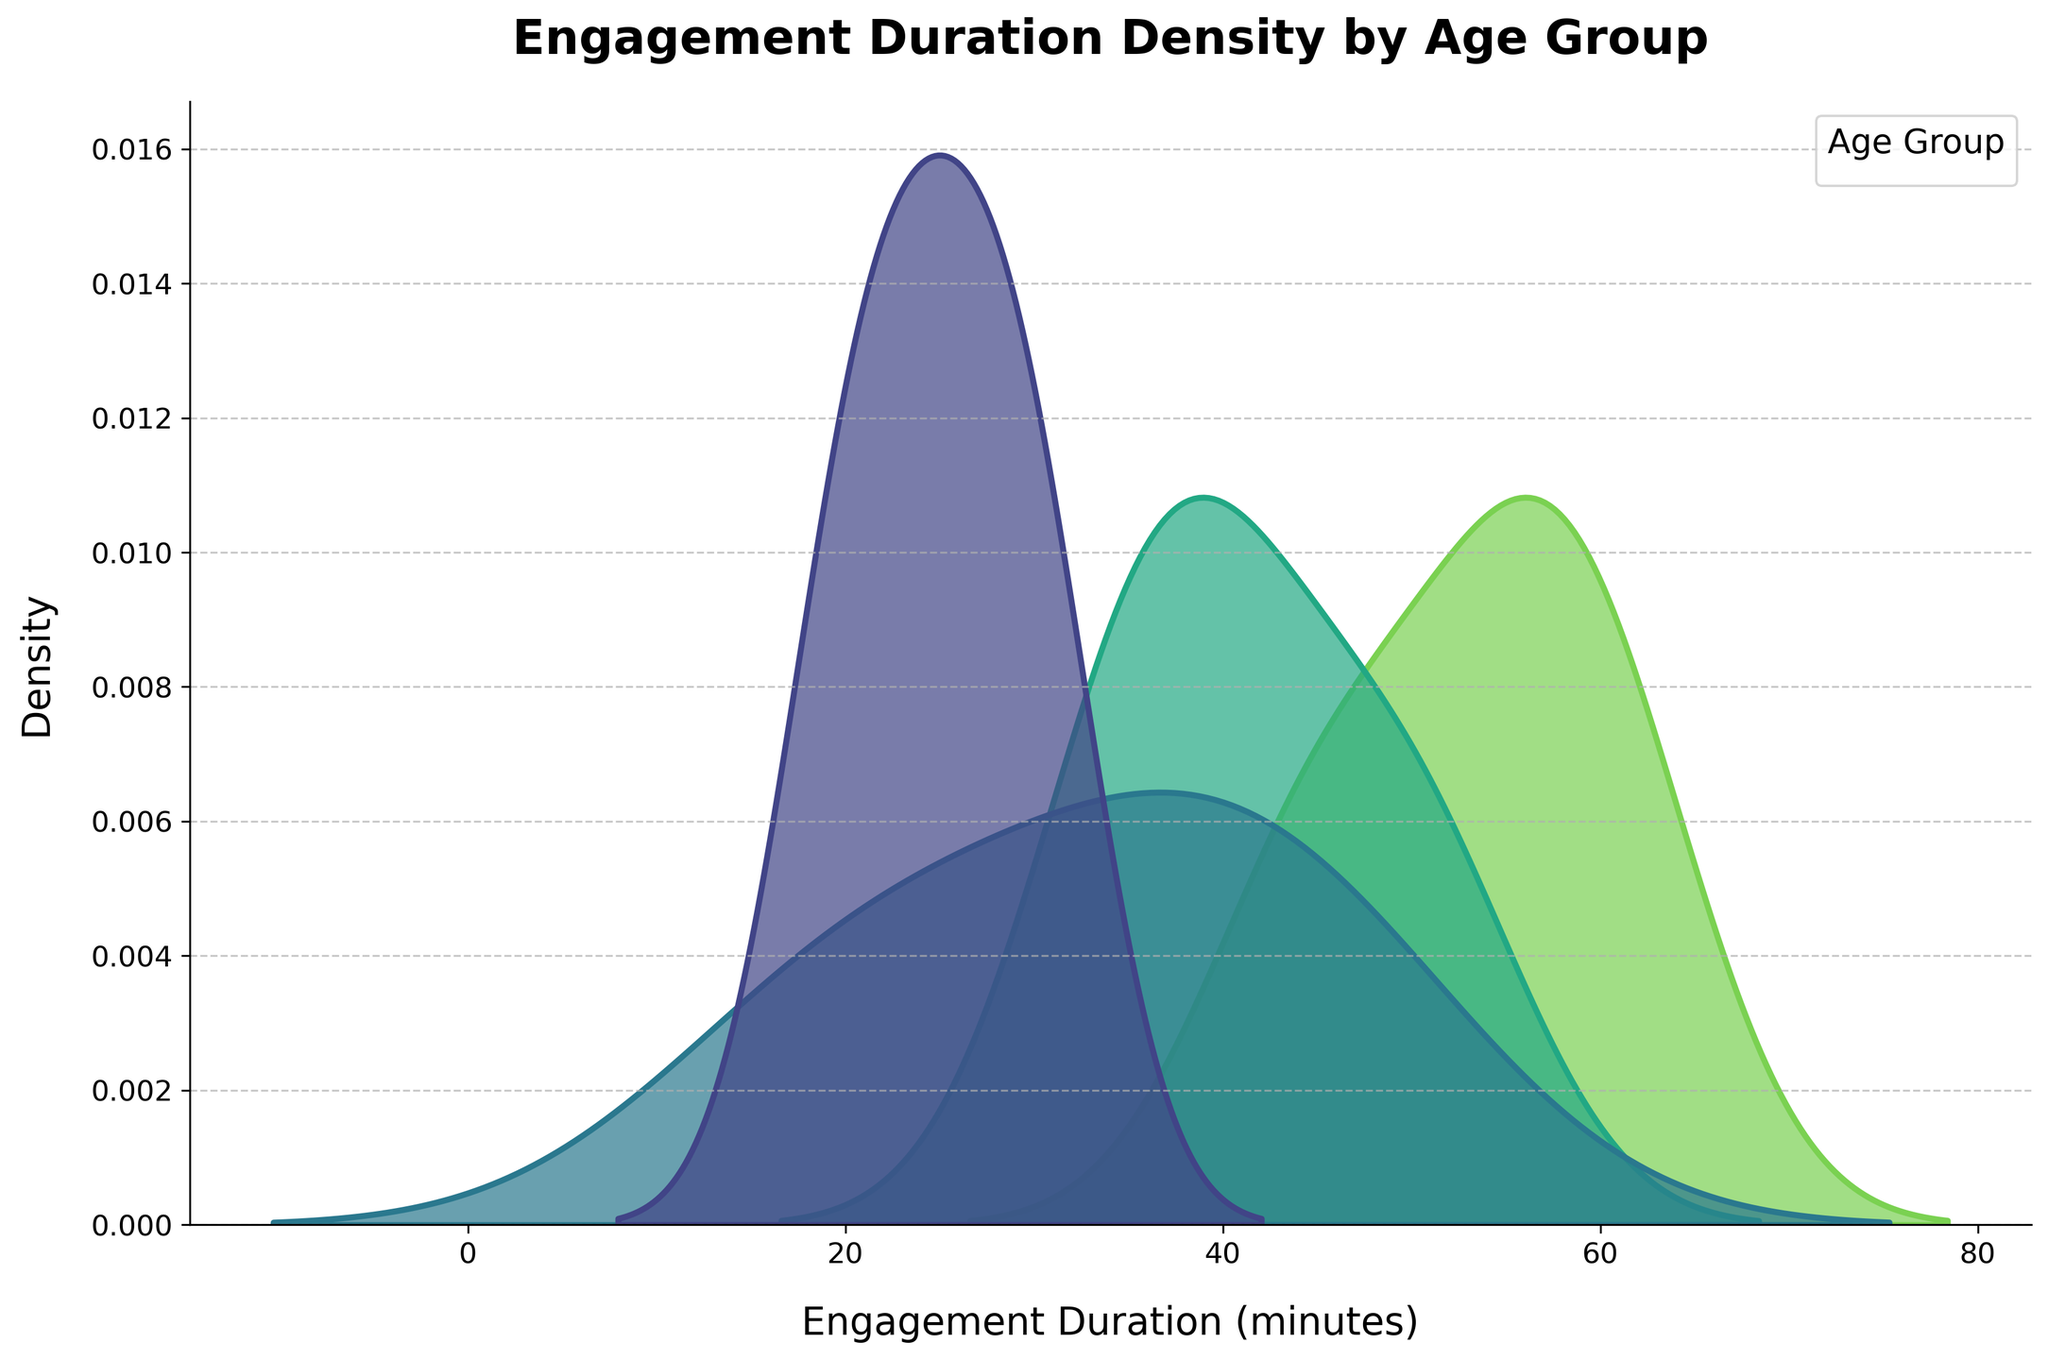what is the title of the figure? The title of the figure is often located at the top and is intended to give a brief description of what the plot is about. In this figure, the title is written in bold and large text.
Answer: Engagement Duration Density by Age Group what is the x-axis labeled as? The x-axis label typically describes what the horizontal axis represents. In this figure, it tells us what measurement is being plotted along this axis.
Answer: Engagement Duration (minutes) how many distinct age groups are represented in the plot? The colors and legend on the plot indicate the different categories or groups the data is divided into. Each distinct color represents a different age group as shown in the legend.
Answer: Four what does the peak density value indicate for each age group? The peak of each density curve represents the value of engagement duration that is most frequent or common within that age group. It is where the density is highest.
Answer: The most common engagement duration within each age group which age group has the highest peak density? To determine this, look at the peaks of each density curve and compare their heights. The highest peak indicates the age group with the most concentrated engagement duration.
Answer: 11-13 which age group shows the largest range of engagement durations? The range of engagement duration is indicated by the spread of the density curve on the x-axis. The group with the widest spread has the largest range.
Answer: 14-16 between which engagement duration do the 8-10 and 11-13 age groups overlap the most? To find the overlap, examine where the density curves for the 8-10 and 11-13 age groups intersect or are closest to each other.
Answer: Around 35-45 minutes for the 5-7 age group, what is the approximate mode of engagement duration? The mode is the value where the peak occurs. For the 5-7 age group, find the highest point on their density curve and read the corresponding x-axis value.
Answer: 30 minutes which age group has the least density around 50 minutes? Identify the density values at 50 minutes for all age groups and find the one that is lowest.
Answer: 5-7 how do the 14-16 and 11-13 age groups differ in terms of their density at 60 minutes? Look at the density curves for both age groups at 60 minutes and compare their heights to see the difference.
Answer: 14-16 has higher density than 11-13 